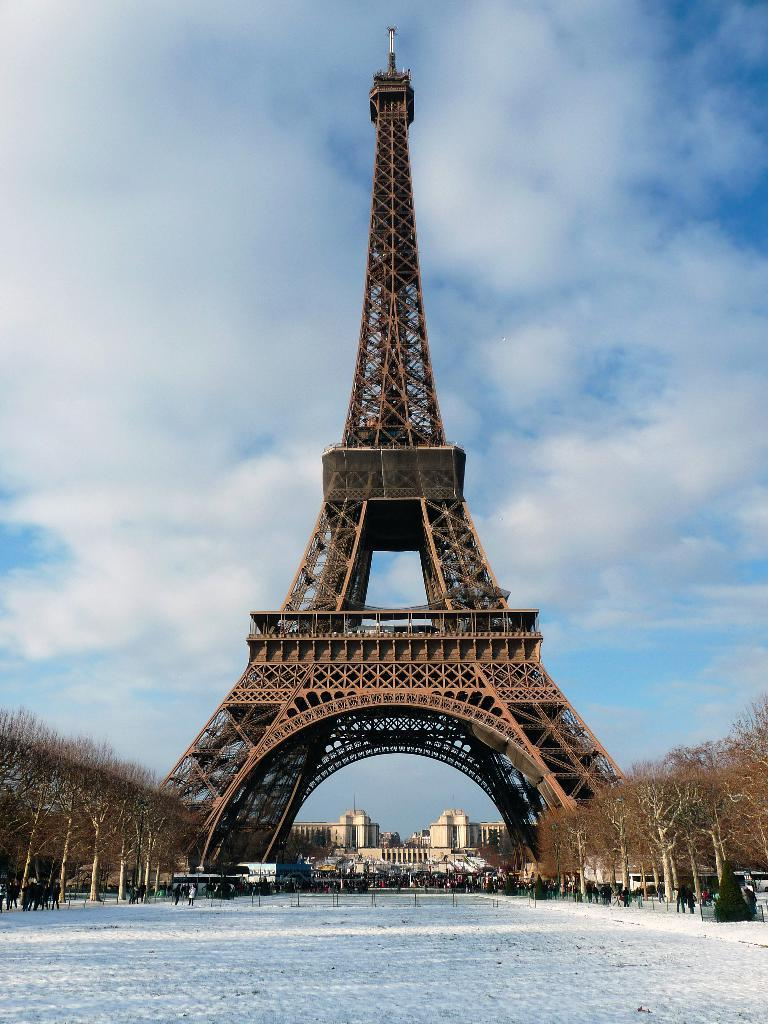What famous landmark can be seen in the image? There is an Eiffel tower in the image. What type of natural elements are present in the image? There are trees in the image. What man-made structures can be seen in the image? Vehicles and buildings are visible in the image. Are there any people in the image? Yes, there is a group of people in the image. What can be seen in the background of the image? The sky is visible in the background of the image, and clouds are present in the sky. How does the group of people comb their hair in the image? There is no indication in the image that the group of people is combing their hair. 